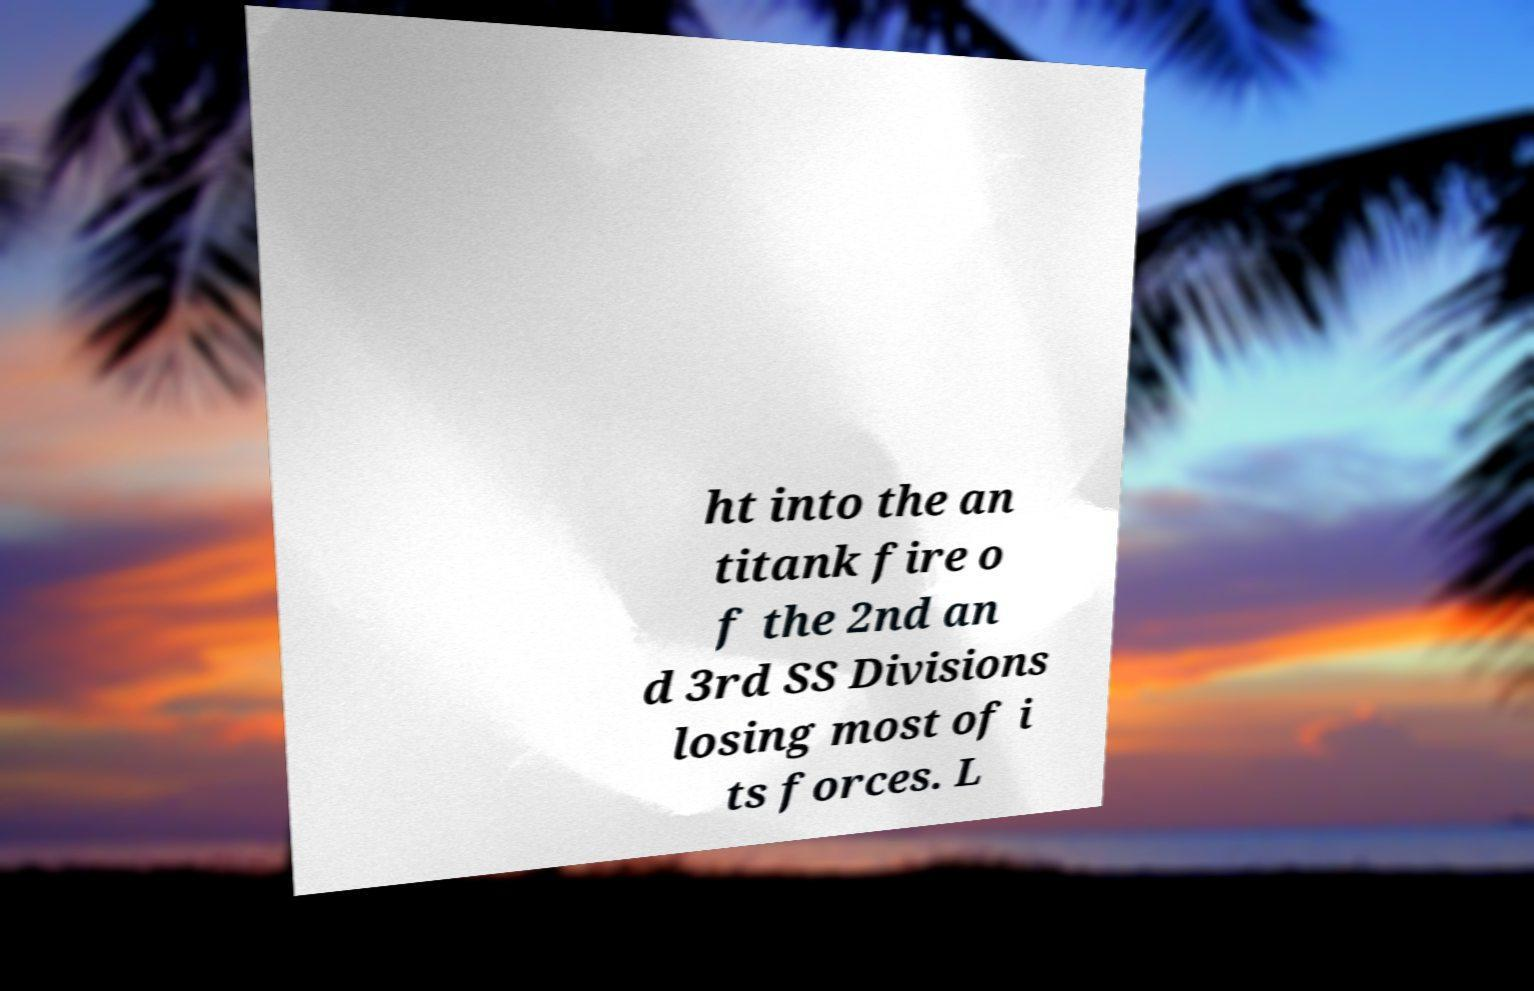Can you accurately transcribe the text from the provided image for me? ht into the an titank fire o f the 2nd an d 3rd SS Divisions losing most of i ts forces. L 